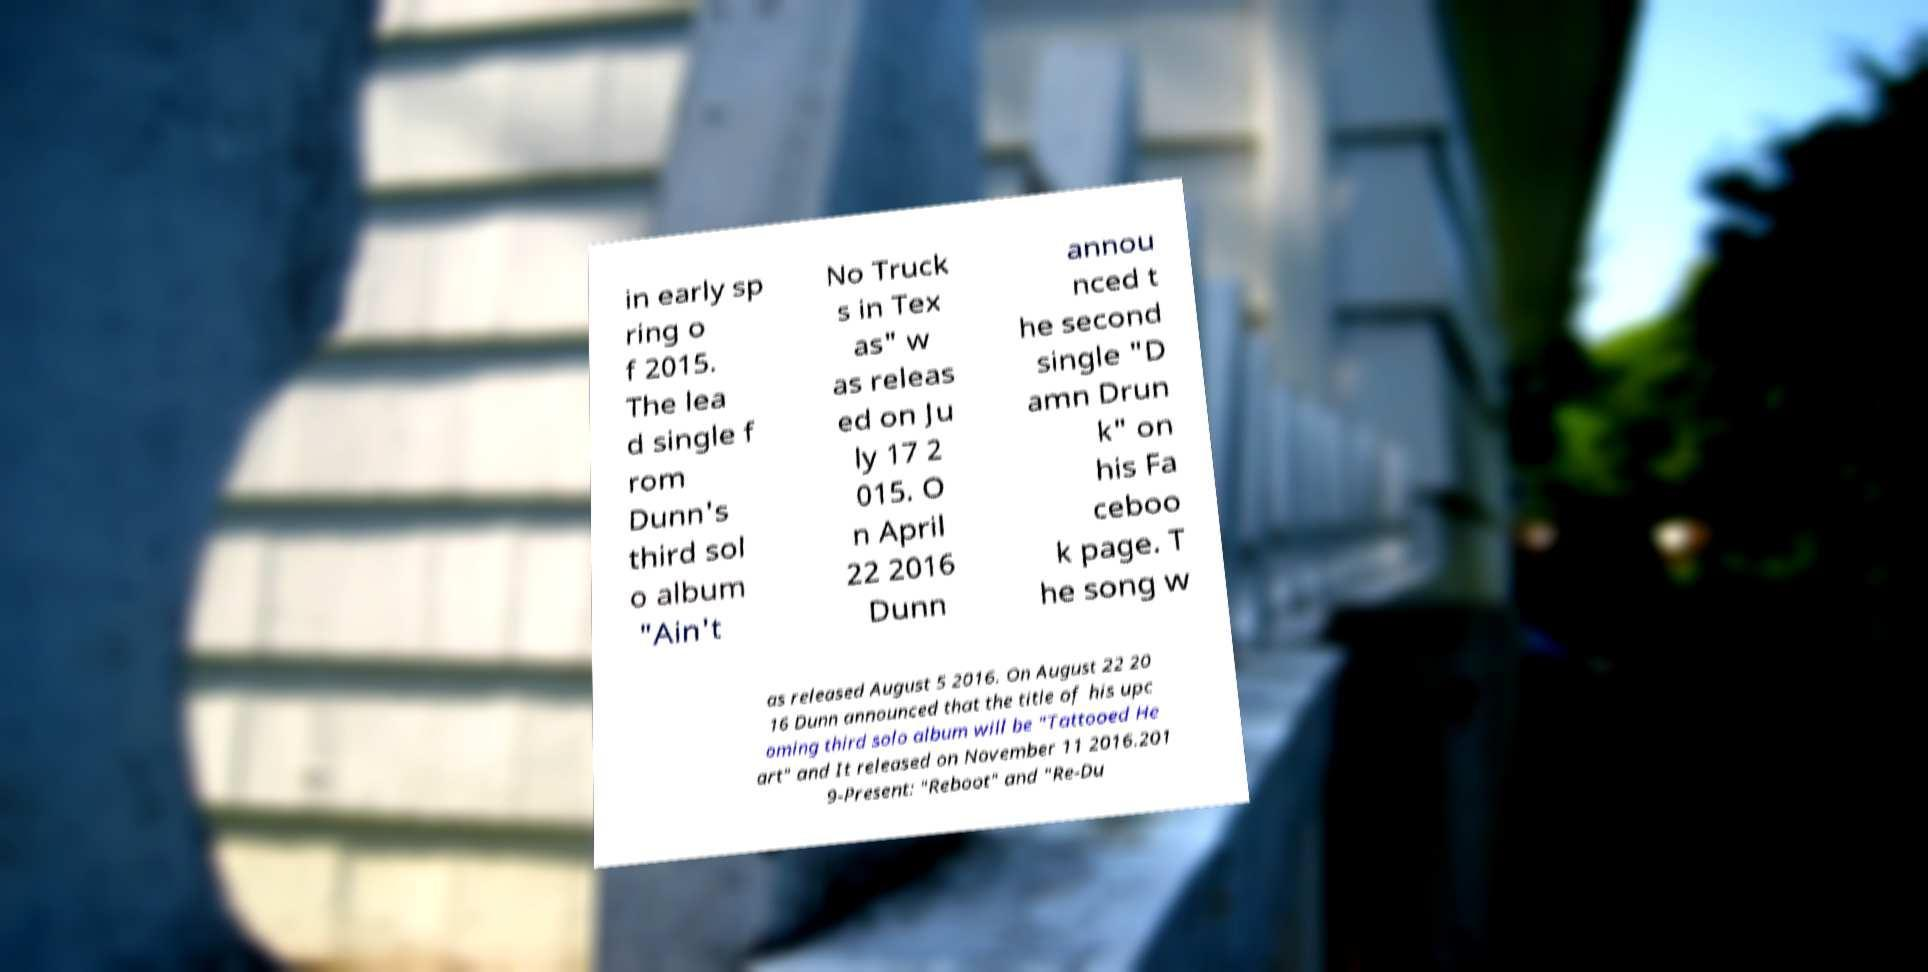Could you extract and type out the text from this image? in early sp ring o f 2015. The lea d single f rom Dunn's third sol o album "Ain't No Truck s in Tex as" w as releas ed on Ju ly 17 2 015. O n April 22 2016 Dunn annou nced t he second single "D amn Drun k" on his Fa ceboo k page. T he song w as released August 5 2016. On August 22 20 16 Dunn announced that the title of his upc oming third solo album will be "Tattooed He art" and It released on November 11 2016.201 9-Present: "Reboot" and "Re-Du 